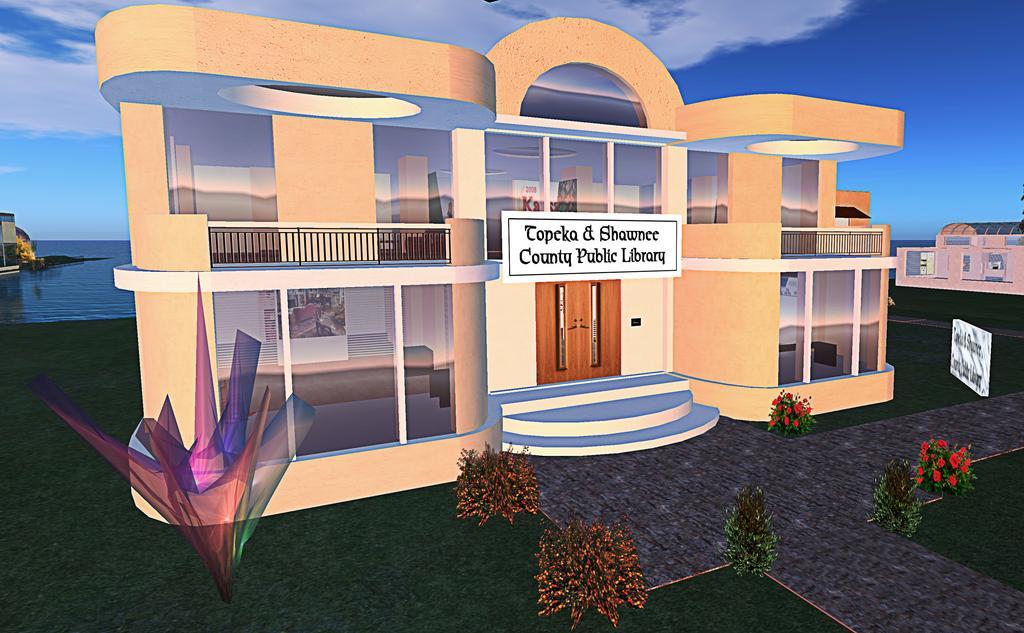Describe this image in one or two sentences. This image is an animation. In this image there are buildings and we can see bushes. There are boards. In the background there is water and we can see the sky. 